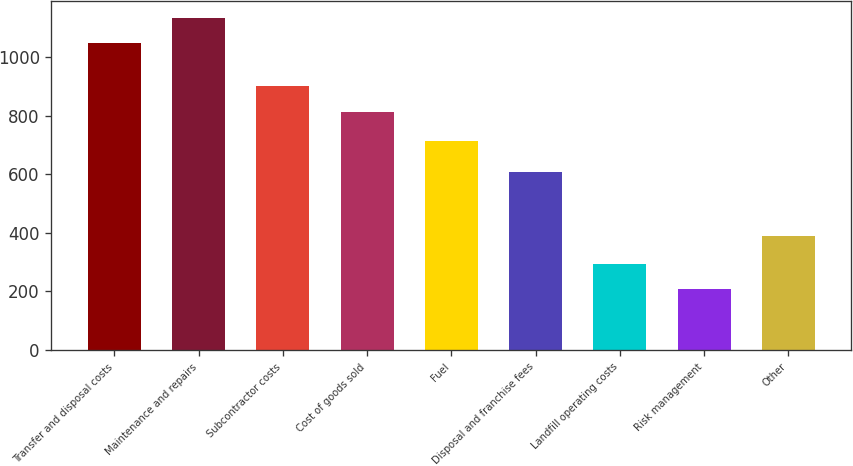<chart> <loc_0><loc_0><loc_500><loc_500><bar_chart><fcel>Transfer and disposal costs<fcel>Maintenance and repairs<fcel>Subcontractor costs<fcel>Cost of goods sold<fcel>Fuel<fcel>Disposal and franchise fees<fcel>Landfill operating costs<fcel>Risk management<fcel>Other<nl><fcel>1048<fcel>1134.5<fcel>901<fcel>812<fcel>715<fcel>608<fcel>295.5<fcel>209<fcel>388<nl></chart> 